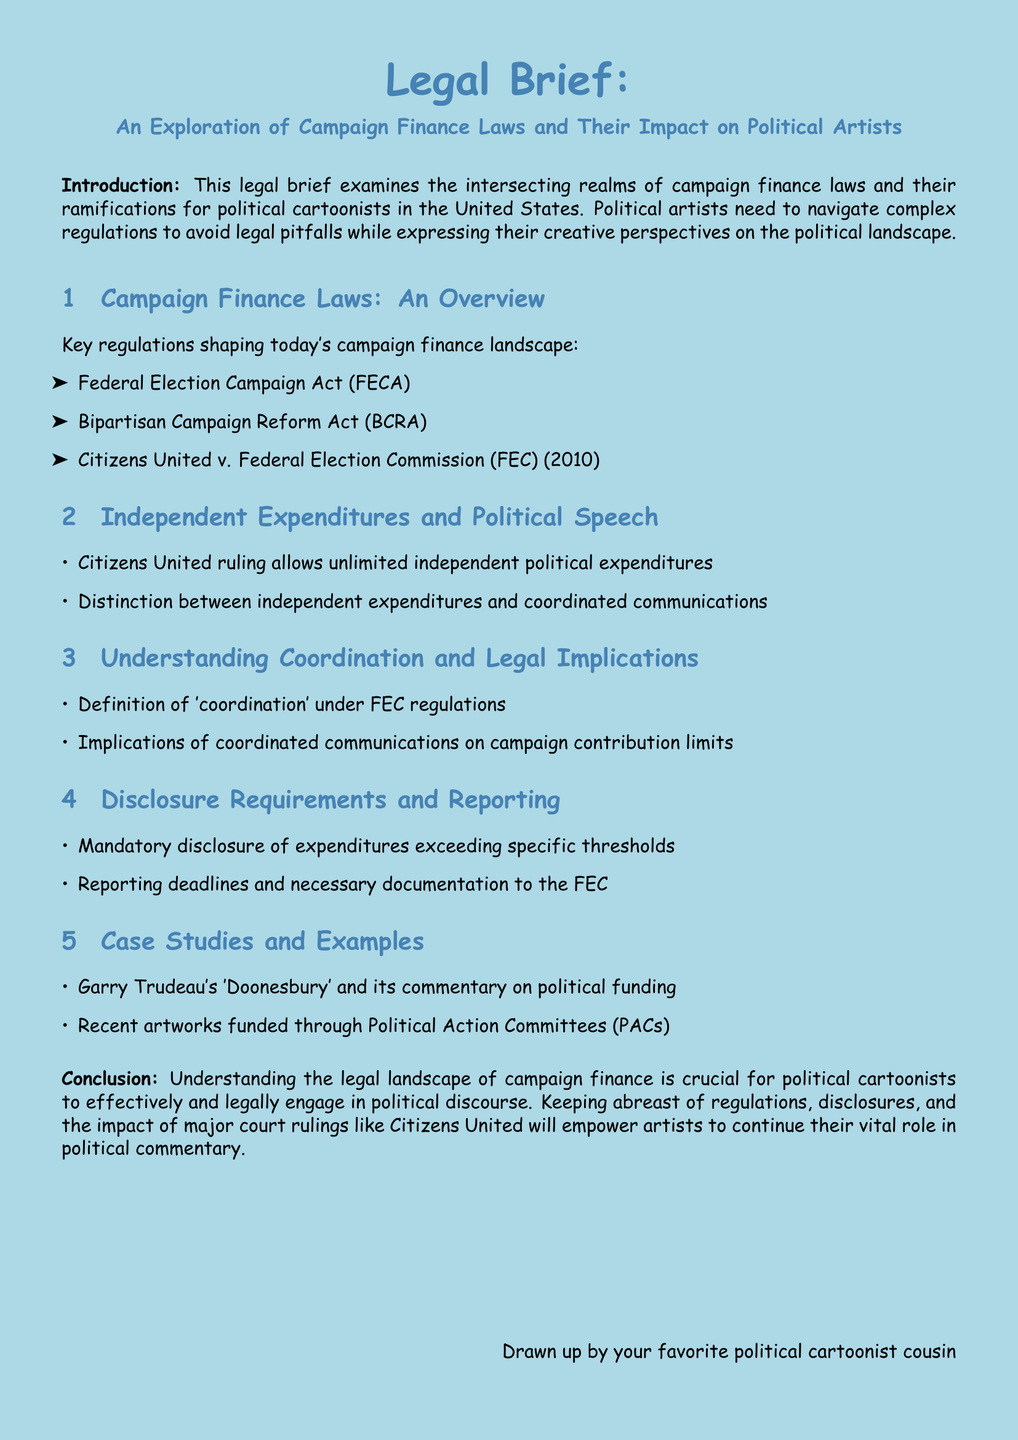What are the key regulations shaping campaign finance? The document lists three key regulations that shape campaign finance laws: FECA, BCRA, and Citizens United v. FEC.
Answer: FECA, BCRA, Citizens United What does the Citizens United ruling allow? The ruling allows unlimited independent political expenditures, which significantly impacts political speech.
Answer: Unlimited independent political expenditures What is the definition of 'coordination' according to FEC regulations? The document refers to a definition of 'coordination' under FEC regulations, indicating a legal concept in campaign finance.
Answer: Definition under FEC regulations What are the mandatory disclosure thresholds mentioned? The brief mentions mandatory disclosure of expenditures exceeding specific thresholds, which are not detailed in this excerpt.
Answer: Specific thresholds Which cartoonist is mentioned as a case study? The document references Garry Trudeau's 'Doonesbury' as a case study related to political funding commentary.
Answer: Garry Trudeau What should political artists keep abreast of? Political artists should stay updated on regulations, disclosures, and major court rulings affecting their work.
Answer: Regulations, disclosures, court rulings What is the purpose of this legal brief? The brief aims to explore how campaign finance laws impact political artists and guide cartoonists in navigating these laws.
Answer: Explore impact on political artists What is the main legal document discussed? The main legal document referred to in the text is the Federal Election Campaign Act (FECA).
Answer: Federal Election Campaign Act (FECA) 